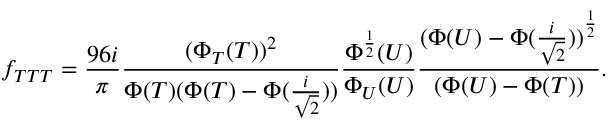<formula> <loc_0><loc_0><loc_500><loc_500>f _ { T T T } = \frac { 9 6 i } { \pi } \frac { ( \Phi _ { T } ( T ) ) ^ { 2 } } { \Phi ( T ) ( \Phi ( T ) - \Phi ( \frac { i } { \sqrt { 2 } } ) ) } \frac { \Phi ^ { \frac { 1 } { 2 } } ( U ) } { \Phi _ { U } ( U ) } \frac { { ( \Phi ( U ) - \Phi ( \frac { i } { \sqrt { 2 } } ) ) } ^ { \frac { 1 } { 2 } } } { ( \Phi ( U ) - \Phi ( T ) ) } .</formula> 